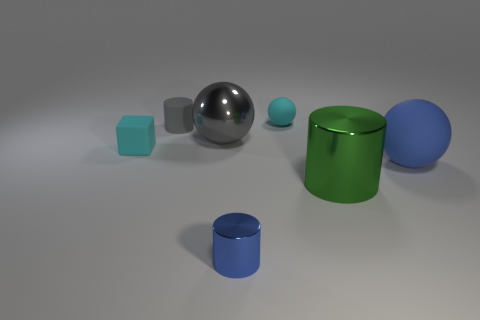What is the size of the gray matte thing?
Offer a very short reply. Small. Is the color of the small rubber sphere the same as the large ball that is in front of the gray metal sphere?
Provide a short and direct response. No. There is a large shiny thing in front of the tiny cyan thing left of the small cyan ball; what is its color?
Ensure brevity in your answer.  Green. Is the shape of the tiny cyan matte thing that is in front of the gray matte cylinder the same as  the tiny blue thing?
Your answer should be very brief. No. How many objects are on the left side of the large cylinder and behind the large cylinder?
Keep it short and to the point. 4. The small thing in front of the cyan thing that is to the left of the large object that is on the left side of the green cylinder is what color?
Your answer should be very brief. Blue. There is a large object to the left of the cyan matte ball; how many cubes are behind it?
Provide a short and direct response. 0. What number of other objects are the same shape as the large gray metallic object?
Keep it short and to the point. 2. What number of things are big gray spheres or cyan matte things to the right of the gray shiny thing?
Make the answer very short. 2. Are there more small rubber things that are to the left of the tiny rubber cylinder than small balls to the right of the tiny cyan rubber sphere?
Offer a terse response. Yes. 